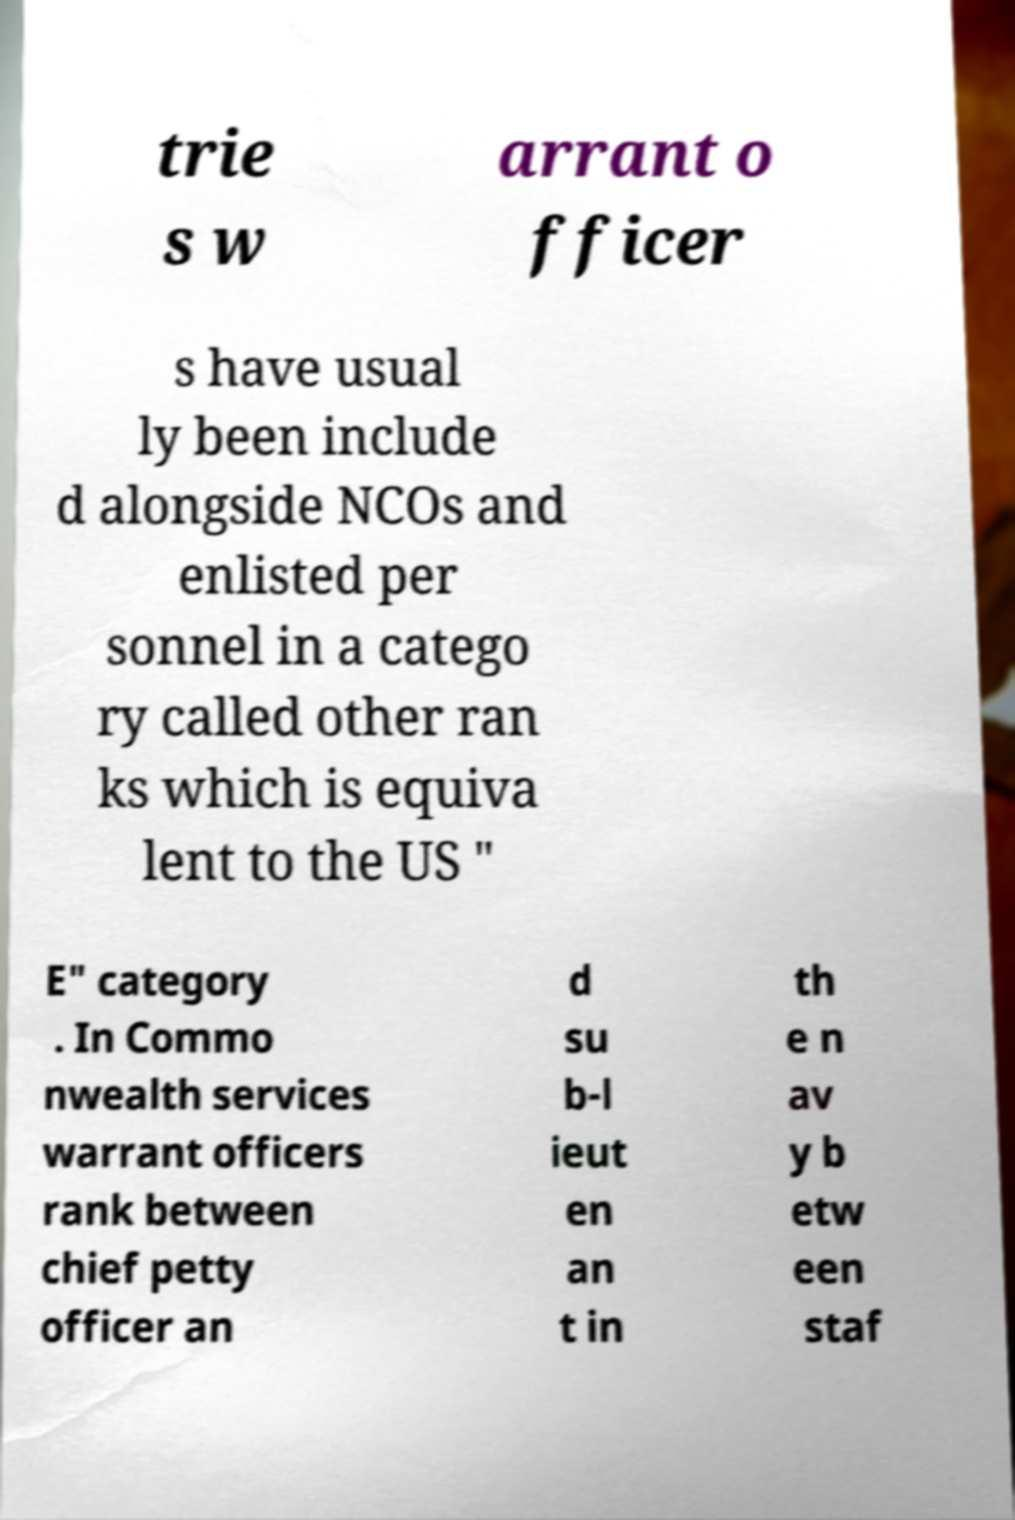Please read and relay the text visible in this image. What does it say? trie s w arrant o fficer s have usual ly been include d alongside NCOs and enlisted per sonnel in a catego ry called other ran ks which is equiva lent to the US " E" category . In Commo nwealth services warrant officers rank between chief petty officer an d su b-l ieut en an t in th e n av y b etw een staf 